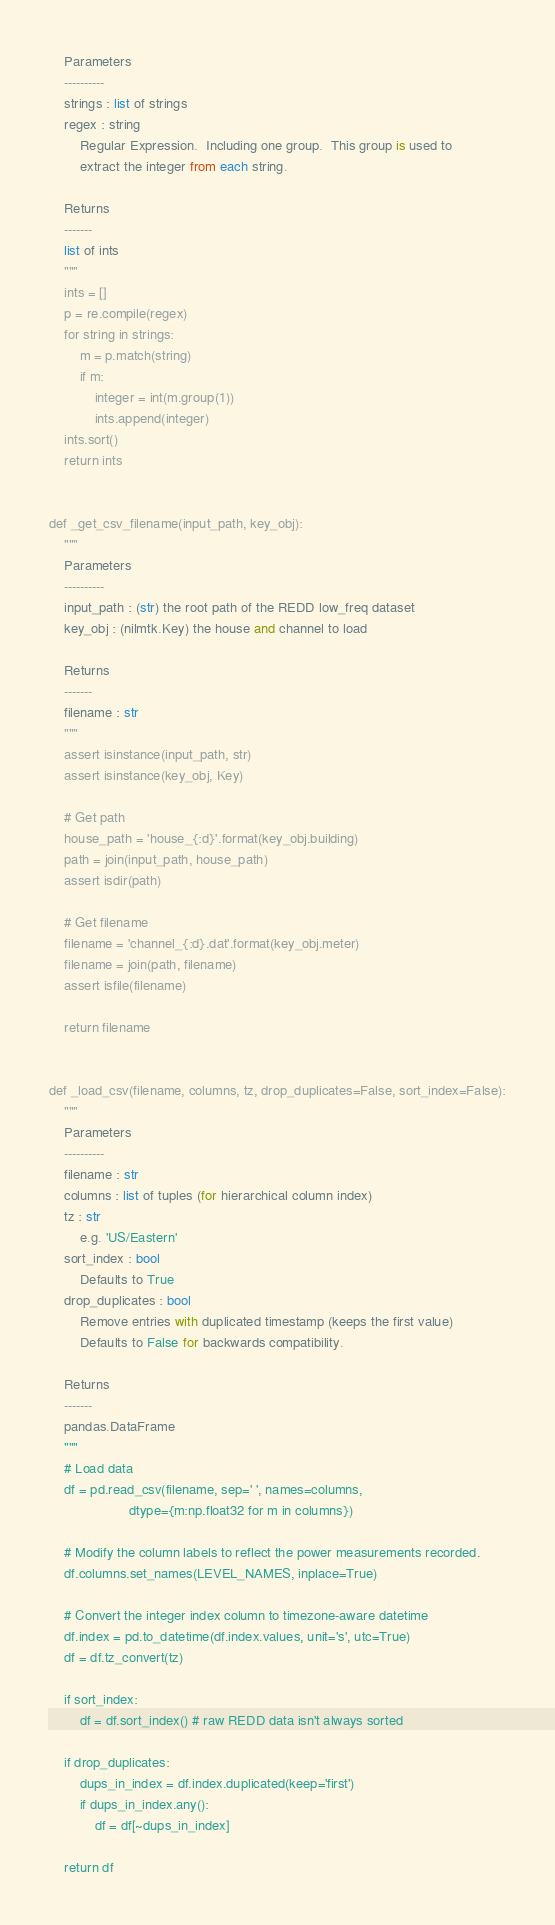<code> <loc_0><loc_0><loc_500><loc_500><_Python_>    Parameters
    ----------
    strings : list of strings
    regex : string
        Regular Expression.  Including one group.  This group is used to
        extract the integer from each string.

    Returns
    -------
    list of ints
    """
    ints = []
    p = re.compile(regex)
    for string in strings:
        m = p.match(string)
        if m:
            integer = int(m.group(1))
            ints.append(integer)
    ints.sort()
    return ints


def _get_csv_filename(input_path, key_obj):
    """
    Parameters
    ----------
    input_path : (str) the root path of the REDD low_freq dataset
    key_obj : (nilmtk.Key) the house and channel to load

    Returns
    ------- 
    filename : str
    """
    assert isinstance(input_path, str)
    assert isinstance(key_obj, Key)

    # Get path
    house_path = 'house_{:d}'.format(key_obj.building)
    path = join(input_path, house_path)
    assert isdir(path)

    # Get filename
    filename = 'channel_{:d}.dat'.format(key_obj.meter)
    filename = join(path, filename)
    assert isfile(filename)

    return filename


def _load_csv(filename, columns, tz, drop_duplicates=False, sort_index=False):
    """
    Parameters
    ----------
    filename : str
    columns : list of tuples (for hierarchical column index)
    tz : str 
        e.g. 'US/Eastern'
    sort_index : bool
        Defaults to True
    drop_duplicates : bool
        Remove entries with duplicated timestamp (keeps the first value)
        Defaults to False for backwards compatibility.

    Returns
    -------
    pandas.DataFrame
    """
    # Load data
    df = pd.read_csv(filename, sep=' ', names=columns,
                     dtype={m:np.float32 for m in columns})
    
    # Modify the column labels to reflect the power measurements recorded.
    df.columns.set_names(LEVEL_NAMES, inplace=True)

    # Convert the integer index column to timezone-aware datetime 
    df.index = pd.to_datetime(df.index.values, unit='s', utc=True)
    df = df.tz_convert(tz)

    if sort_index:
        df = df.sort_index() # raw REDD data isn't always sorted
        
    if drop_duplicates:
        dups_in_index = df.index.duplicated(keep='first')
        if dups_in_index.any():
            df = df[~dups_in_index]

    return df
</code> 